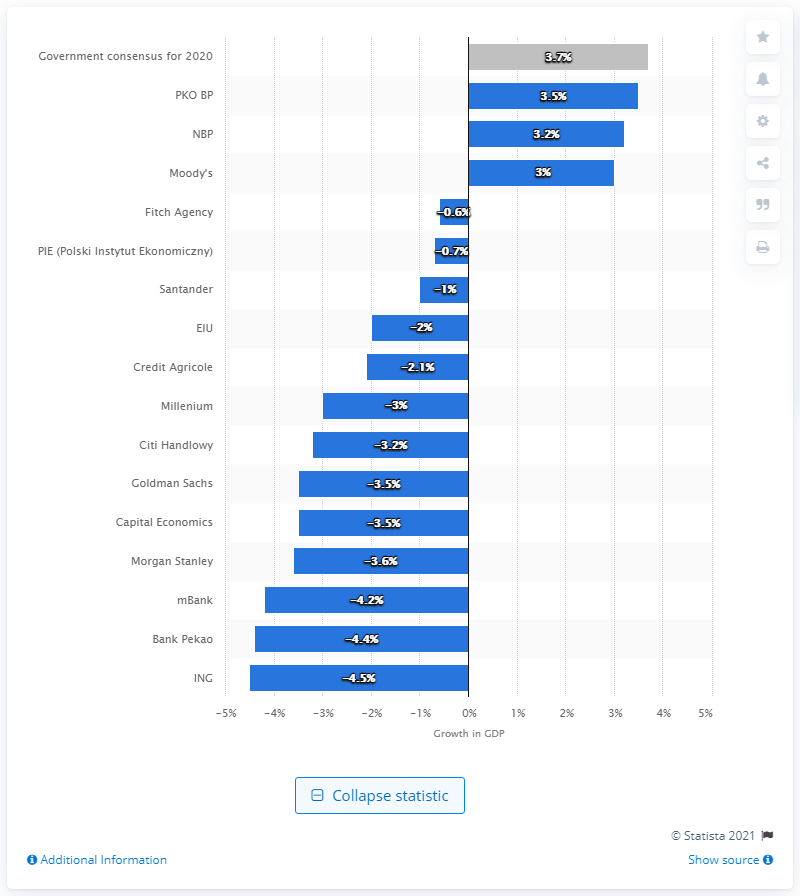Mention a couple of crucial points in this snapshot. The estimated GDP index at the end of 2019 was 3.7. The largest bank in Poland is PKO BP. 